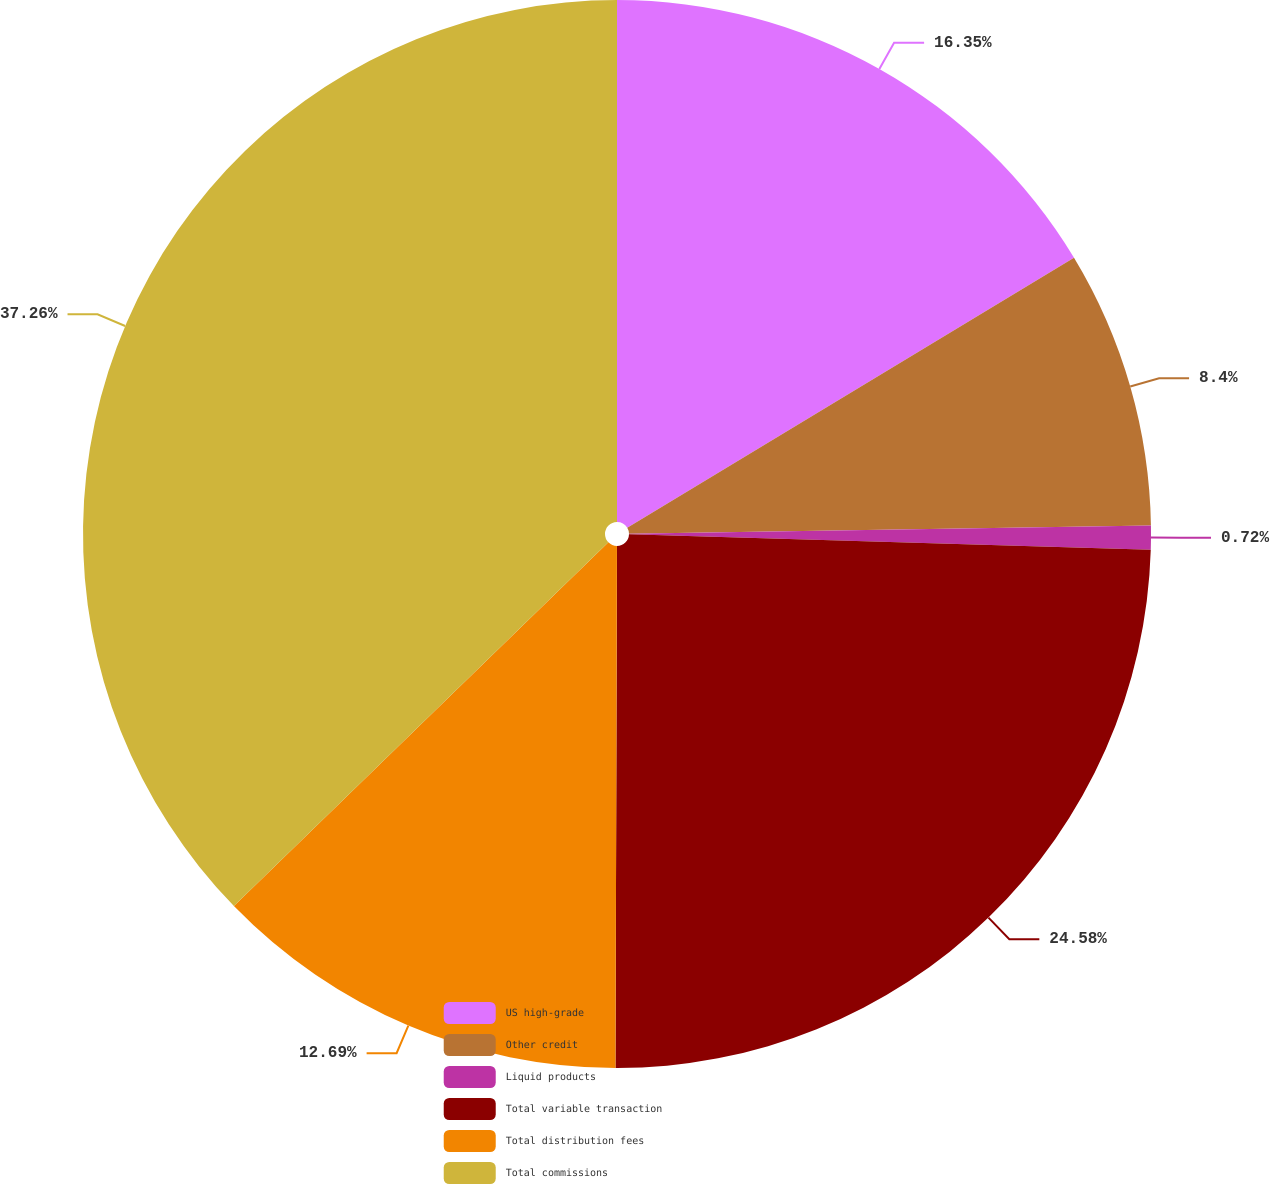Convert chart to OTSL. <chart><loc_0><loc_0><loc_500><loc_500><pie_chart><fcel>US high-grade<fcel>Other credit<fcel>Liquid products<fcel>Total variable transaction<fcel>Total distribution fees<fcel>Total commissions<nl><fcel>16.35%<fcel>8.4%<fcel>0.72%<fcel>24.58%<fcel>12.69%<fcel>37.27%<nl></chart> 